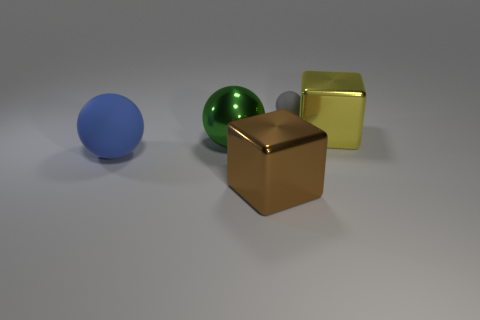What number of things are either large metal objects to the left of the small gray matte thing or balls?
Provide a succinct answer. 4. Are there the same number of metallic spheres in front of the large brown block and large blue balls behind the tiny gray thing?
Offer a very short reply. Yes. What number of other things are there of the same shape as the gray matte object?
Your answer should be very brief. 2. There is a cube that is in front of the metallic ball; is it the same size as the object to the right of the tiny gray ball?
Your response must be concise. Yes. How many cylinders are tiny purple matte objects or green shiny objects?
Keep it short and to the point. 0. What number of matte objects are either green things or large blue things?
Ensure brevity in your answer.  1. What is the size of the gray rubber thing that is the same shape as the green metal thing?
Give a very brief answer. Small. Are there any other things that are the same size as the gray sphere?
Offer a very short reply. No. Does the brown metal thing have the same size as the block behind the green metal ball?
Provide a short and direct response. Yes. The rubber thing right of the brown metallic block has what shape?
Your answer should be very brief. Sphere. 